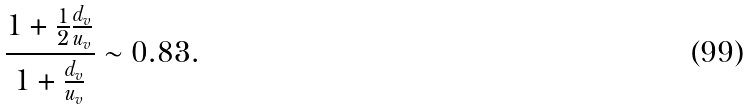<formula> <loc_0><loc_0><loc_500><loc_500>\frac { 1 + \frac { 1 } { 2 } \frac { d _ { v } } { u _ { v } } } { 1 + \frac { d _ { v } } { u _ { v } } } \sim 0 . 8 3 .</formula> 